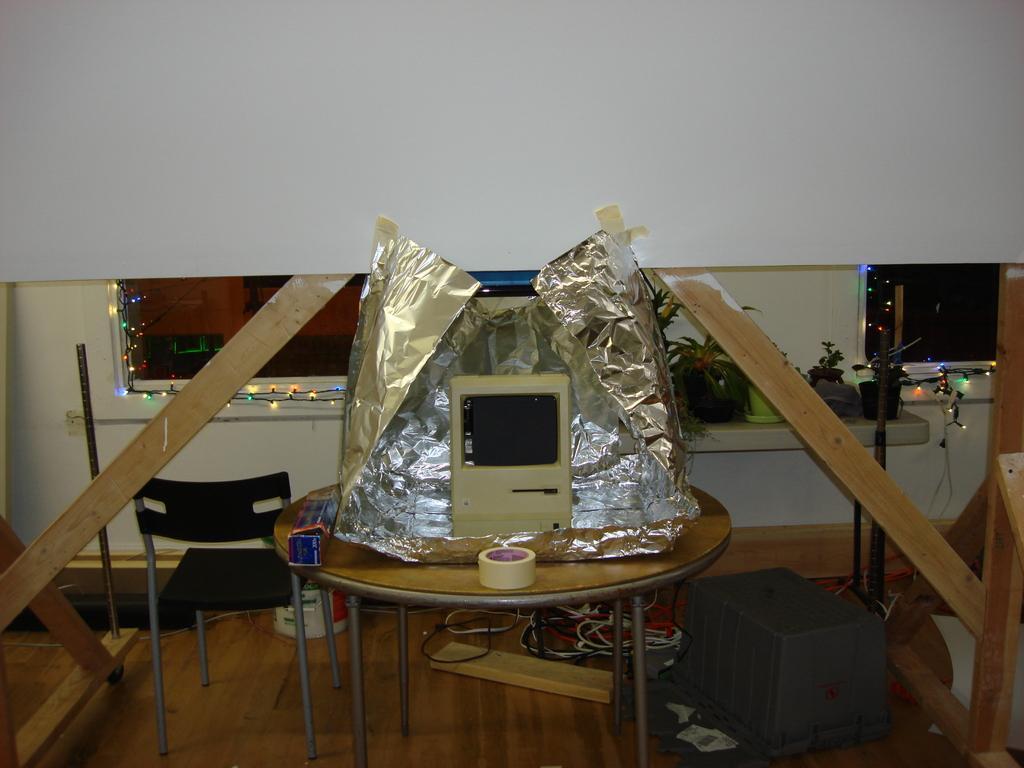How would you summarize this image in a sentence or two? In this image, we can see a table with some objects like a tape, aluminium foil. We can also see some chairs. We can see some wood. We can see the ground with some objects. We can see the wall. We can see some plants. We can see some lights and we can see a white colored object. 